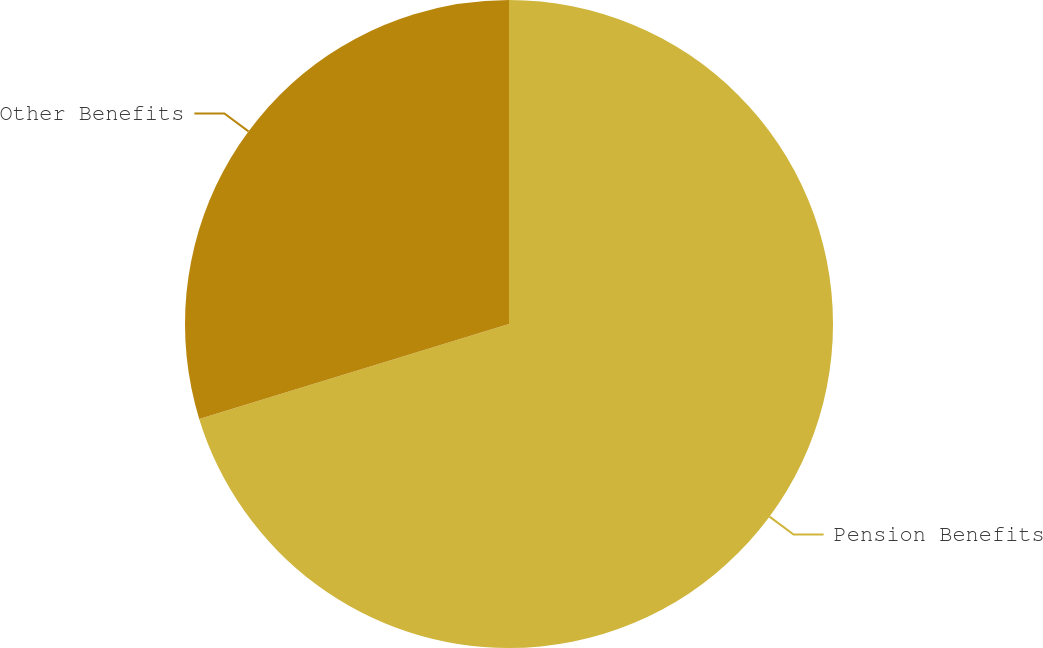<chart> <loc_0><loc_0><loc_500><loc_500><pie_chart><fcel>Pension Benefits<fcel>Other Benefits<nl><fcel>70.27%<fcel>29.73%<nl></chart> 